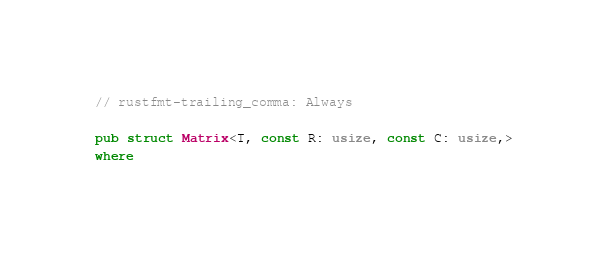<code> <loc_0><loc_0><loc_500><loc_500><_Rust_>// rustfmt-trailing_comma: Always

pub struct Matrix<T, const R: usize, const C: usize,>
where</code> 